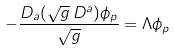Convert formula to latex. <formula><loc_0><loc_0><loc_500><loc_500>- \frac { D _ { a } ( \sqrt { g } \, D ^ { a } ) \phi _ { p } } { \sqrt { g } } = \Lambda \phi _ { p }</formula> 